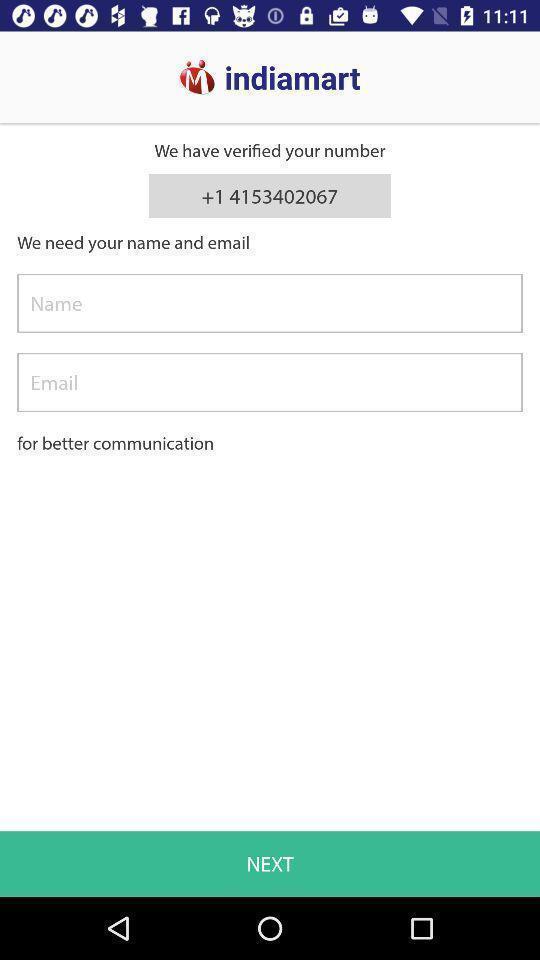Tell me what you see in this picture. Screen displays login page. 